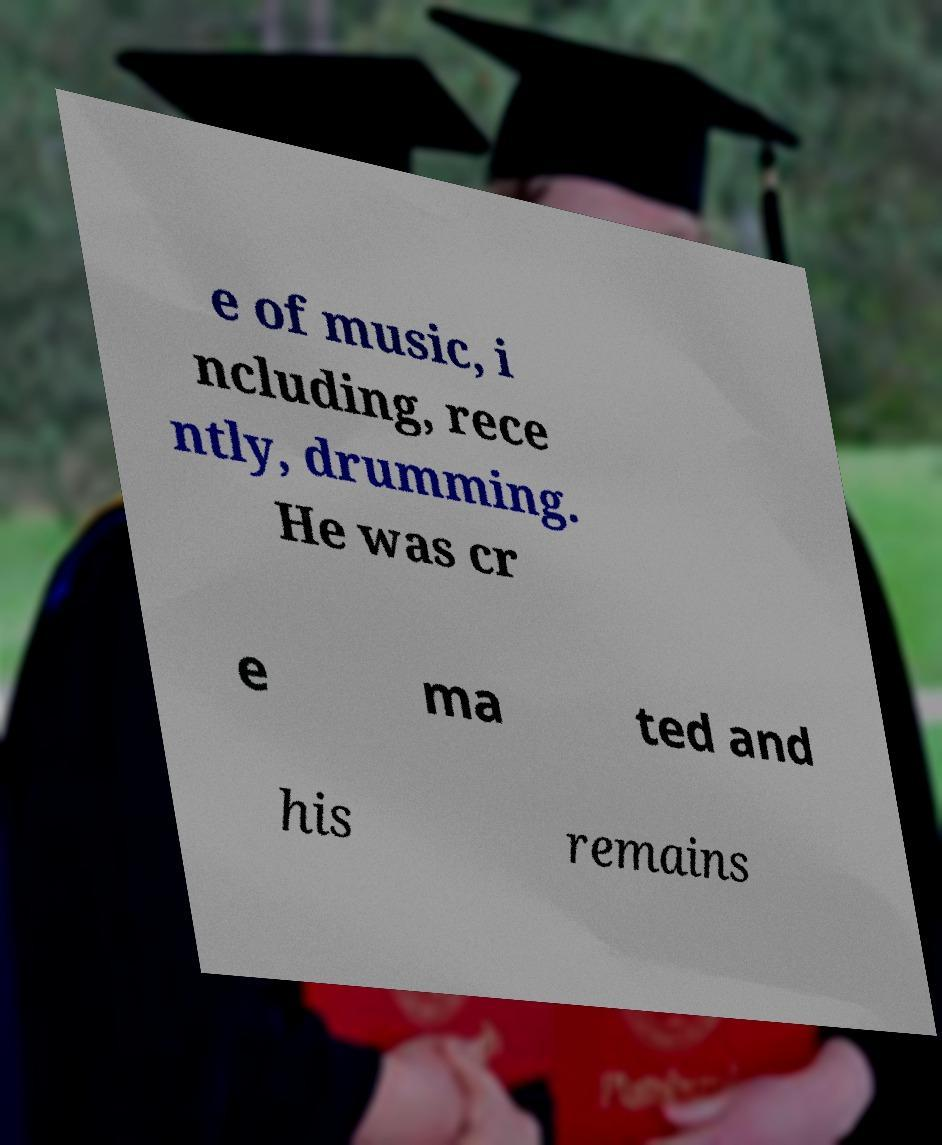Please identify and transcribe the text found in this image. e of music, i ncluding, rece ntly, drumming. He was cr e ma ted and his remains 